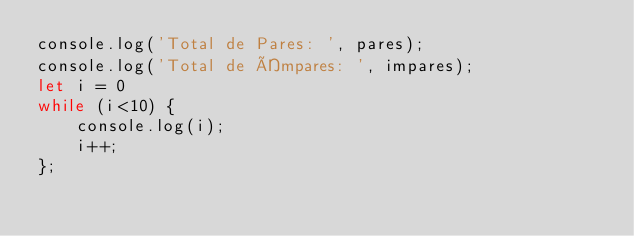Convert code to text. <code><loc_0><loc_0><loc_500><loc_500><_JavaScript_>console.log('Total de Pares: ', pares);
console.log('Total de Ímpares: ', impares);
let i = 0
while (i<10) {
    console.log(i);
    i++;
};</code> 